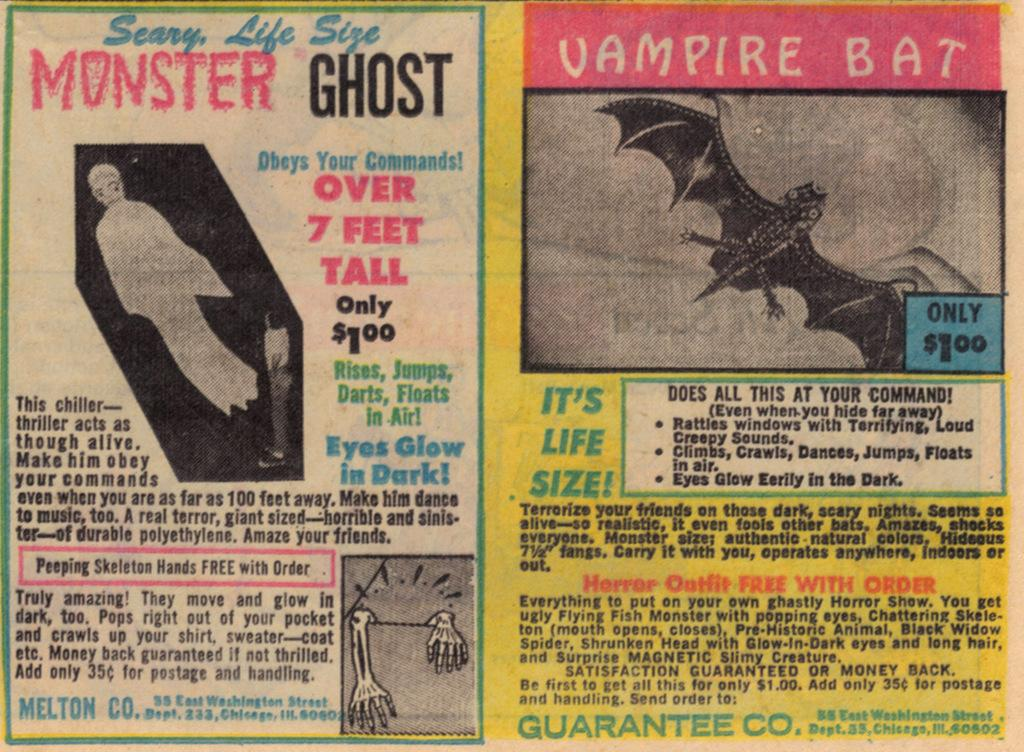<image>
Share a concise interpretation of the image provided. Magazine page that shows a picture of a bat and the words Vampire Bat above it. 